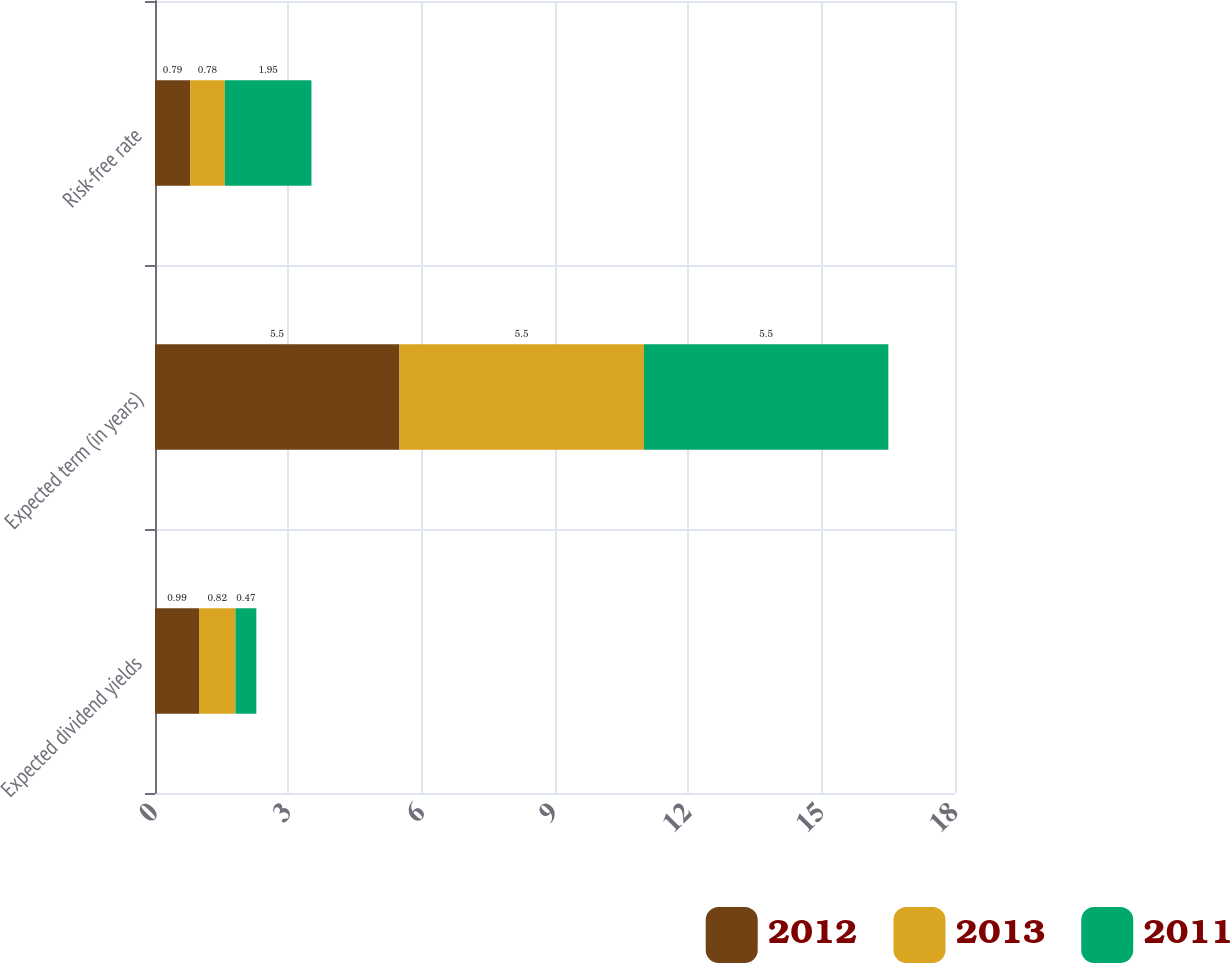Convert chart. <chart><loc_0><loc_0><loc_500><loc_500><stacked_bar_chart><ecel><fcel>Expected dividend yields<fcel>Expected term (in years)<fcel>Risk-free rate<nl><fcel>2012<fcel>0.99<fcel>5.5<fcel>0.79<nl><fcel>2013<fcel>0.82<fcel>5.5<fcel>0.78<nl><fcel>2011<fcel>0.47<fcel>5.5<fcel>1.95<nl></chart> 